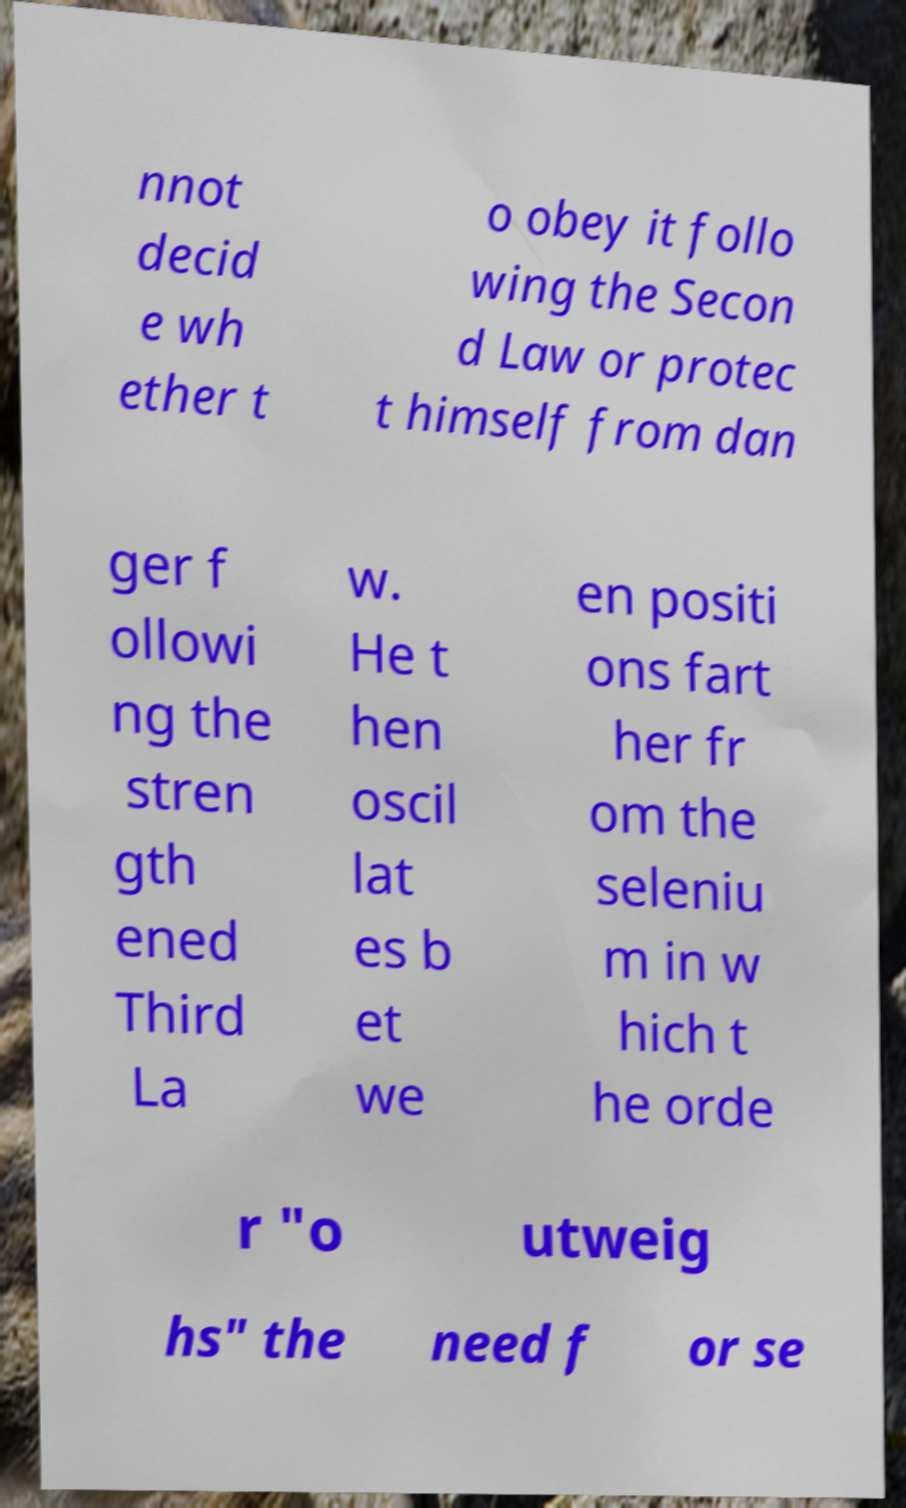Can you accurately transcribe the text from the provided image for me? nnot decid e wh ether t o obey it follo wing the Secon d Law or protec t himself from dan ger f ollowi ng the stren gth ened Third La w. He t hen oscil lat es b et we en positi ons fart her fr om the seleniu m in w hich t he orde r "o utweig hs" the need f or se 